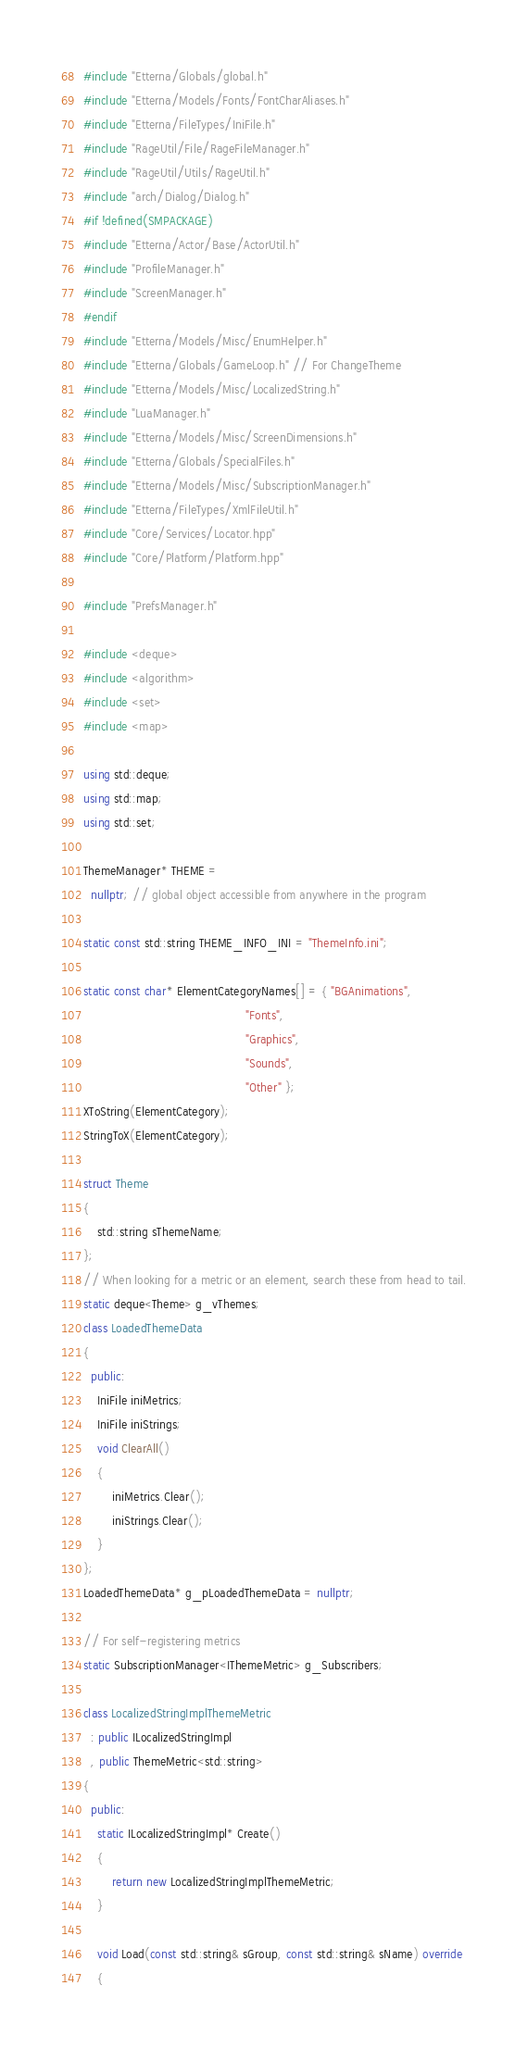Convert code to text. <code><loc_0><loc_0><loc_500><loc_500><_C++_>#include "Etterna/Globals/global.h"
#include "Etterna/Models/Fonts/FontCharAliases.h"
#include "Etterna/FileTypes/IniFile.h"
#include "RageUtil/File/RageFileManager.h"
#include "RageUtil/Utils/RageUtil.h"
#include "arch/Dialog/Dialog.h"
#if !defined(SMPACKAGE)
#include "Etterna/Actor/Base/ActorUtil.h"
#include "ProfileManager.h"
#include "ScreenManager.h"
#endif
#include "Etterna/Models/Misc/EnumHelper.h"
#include "Etterna/Globals/GameLoop.h" // For ChangeTheme
#include "Etterna/Models/Misc/LocalizedString.h"
#include "LuaManager.h"
#include "Etterna/Models/Misc/ScreenDimensions.h"
#include "Etterna/Globals/SpecialFiles.h"
#include "Etterna/Models/Misc/SubscriptionManager.h"
#include "Etterna/FileTypes/XmlFileUtil.h"
#include "Core/Services/Locator.hpp"
#include "Core/Platform/Platform.hpp"

#include "PrefsManager.h"

#include <deque>
#include <algorithm>
#include <set>
#include <map>

using std::deque;
using std::map;
using std::set;

ThemeManager* THEME =
  nullptr; // global object accessible from anywhere in the program

static const std::string THEME_INFO_INI = "ThemeInfo.ini";

static const char* ElementCategoryNames[] = { "BGAnimations",
											  "Fonts",
											  "Graphics",
											  "Sounds",
											  "Other" };
XToString(ElementCategory);
StringToX(ElementCategory);

struct Theme
{
	std::string sThemeName;
};
// When looking for a metric or an element, search these from head to tail.
static deque<Theme> g_vThemes;
class LoadedThemeData
{
  public:
	IniFile iniMetrics;
	IniFile iniStrings;
	void ClearAll()
	{
		iniMetrics.Clear();
		iniStrings.Clear();
	}
};
LoadedThemeData* g_pLoadedThemeData = nullptr;

// For self-registering metrics
static SubscriptionManager<IThemeMetric> g_Subscribers;

class LocalizedStringImplThemeMetric
  : public ILocalizedStringImpl
  , public ThemeMetric<std::string>
{
  public:
	static ILocalizedStringImpl* Create()
	{
		return new LocalizedStringImplThemeMetric;
	}

	void Load(const std::string& sGroup, const std::string& sName) override
	{</code> 